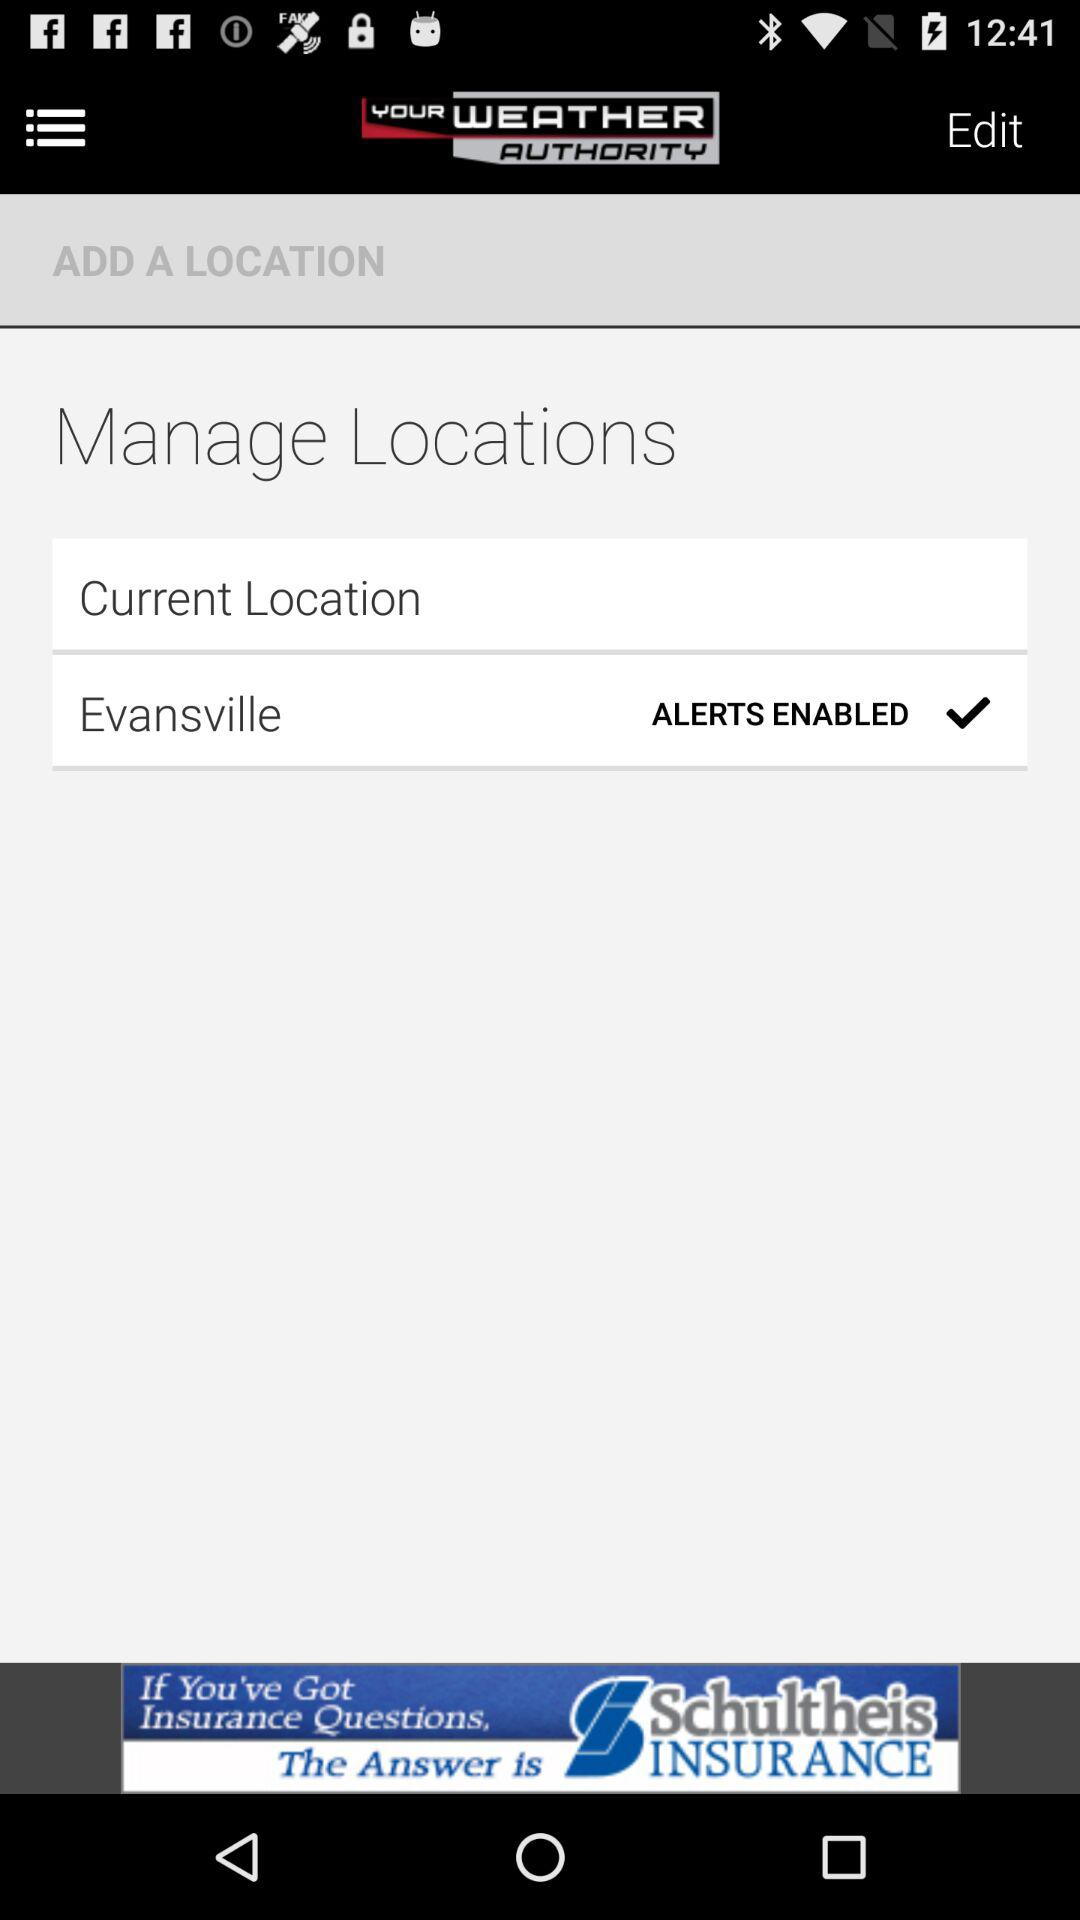How many alerts are enabled?
Answer the question using a single word or phrase. 1 